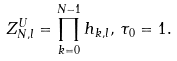<formula> <loc_0><loc_0><loc_500><loc_500>Z _ { N , l } ^ { U } = \prod _ { k = 0 } ^ { N - 1 } h _ { k , l } , \, \tau _ { 0 } = 1 .</formula> 